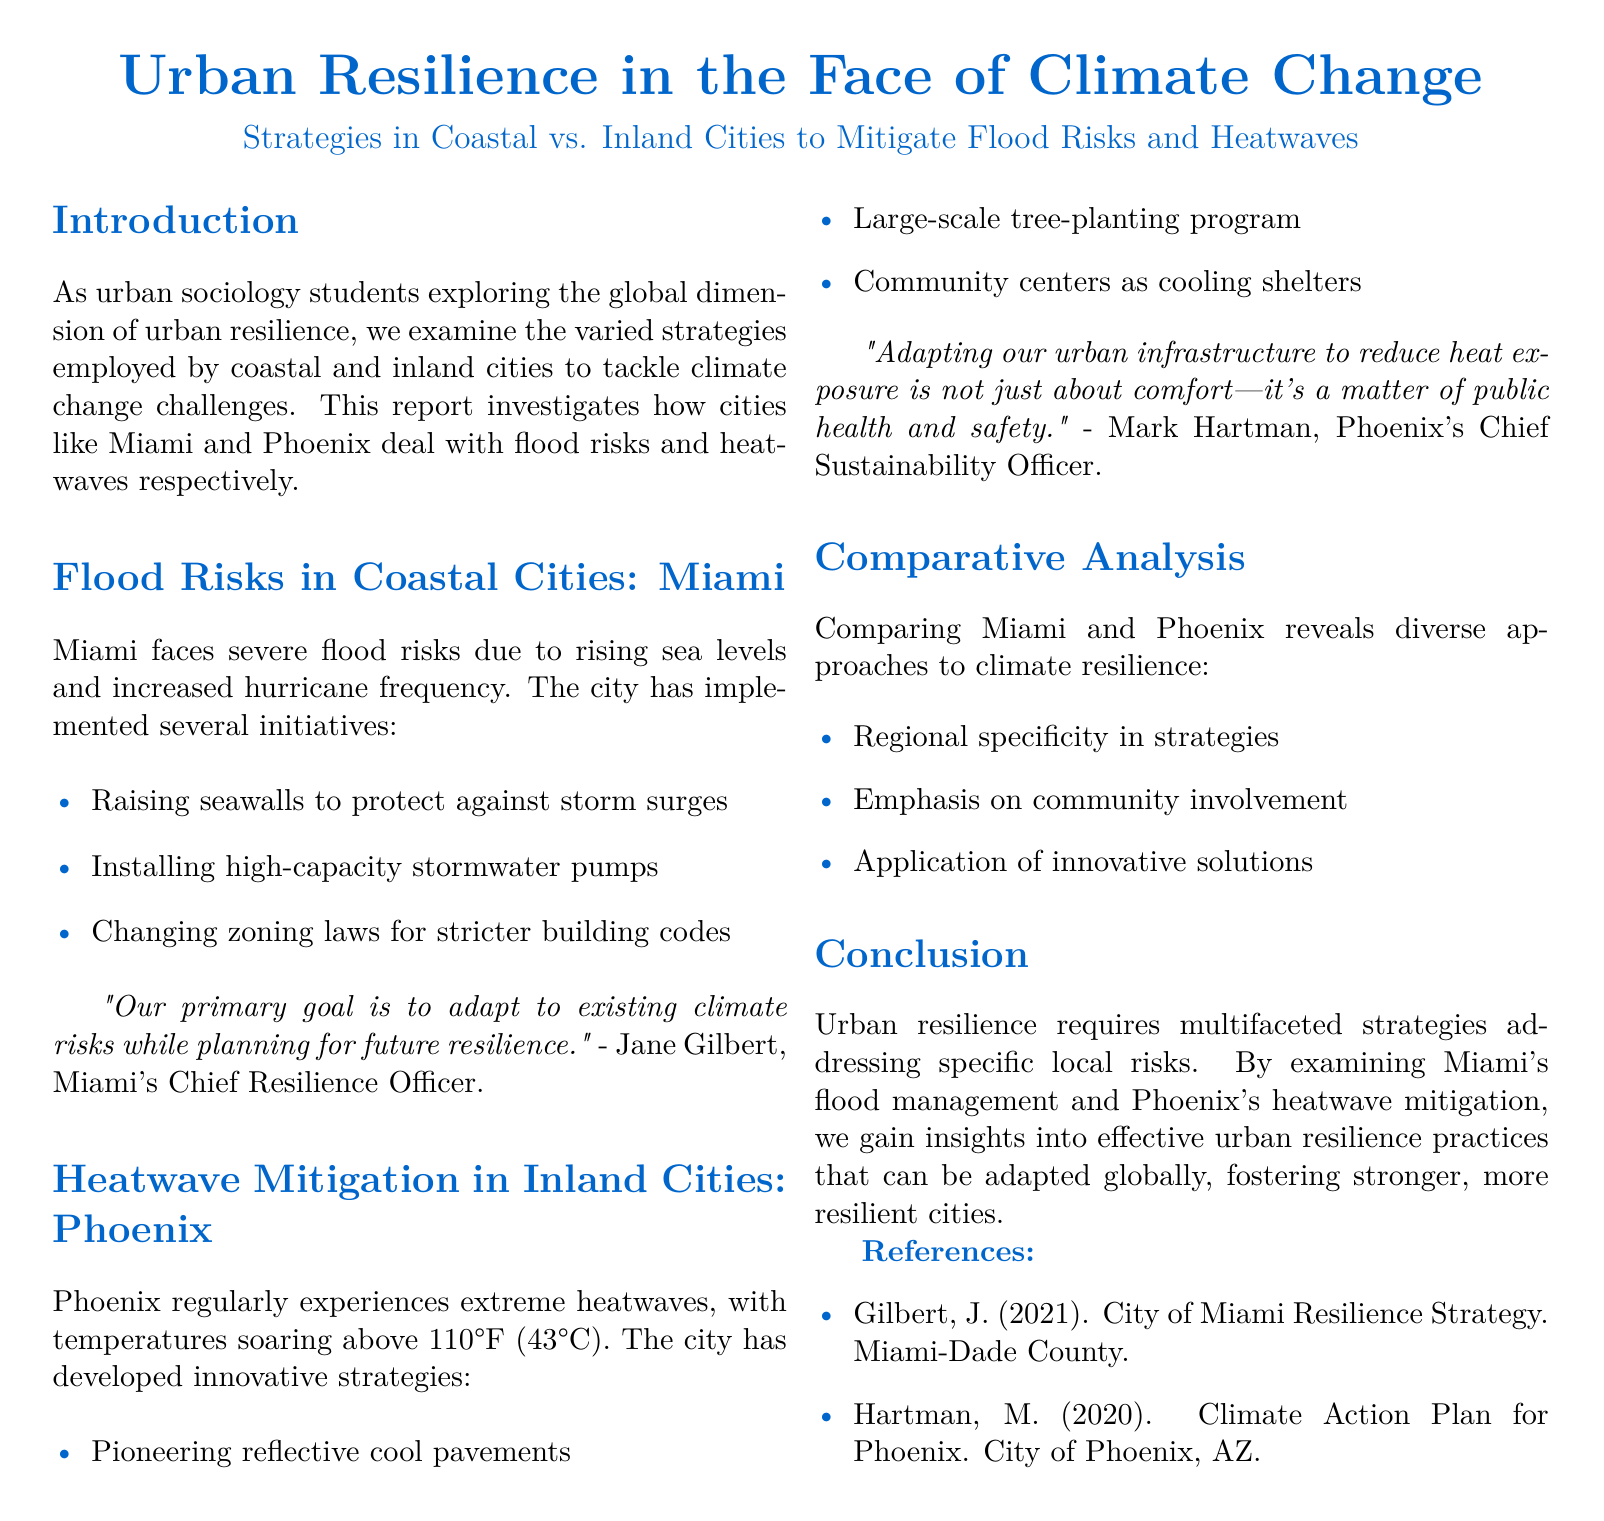what is the main subject of the report? The report focuses on urban resilience strategies in the context of climate change, specifically comparing coastal and inland cities.
Answer: Urban resilience which coastal city is discussed in the report? The report mentions Miami as an example of a coastal city facing flood risks.
Answer: Miami what key strategy is employed by Miami to mitigate flood risks? The document lists raising seawalls as one initiative implemented by Miami.
Answer: Raising seawalls what is a significant heatwave strategy used in Phoenix? The report highlights a large-scale tree-planting program as a key strategy in Phoenix.
Answer: Large-scale tree-planting program who is the Chief Resilience Officer of Miami? The document states that Jane Gilbert holds the position of Chief Resilience Officer in Miami.
Answer: Jane Gilbert how does Phoenix address public health related to heatwaves? The document mentions community centers as cooling shelters related to public health and heatwaves.
Answer: Cooling shelters what is one common aspect of the strategies used by both cities? The report notes an emphasis on community involvement as a shared focus of the strategies.
Answer: Community involvement which year is cited for Jane Gilbert's quote in the references? The reference for Jane Gilbert’s quote is dated 2021.
Answer: 2021 what is the temperature threshold commonly experienced in Phoenix? Phoenix is noted for regularly experiencing temperatures above 110°F (43°C).
Answer: 110°F 